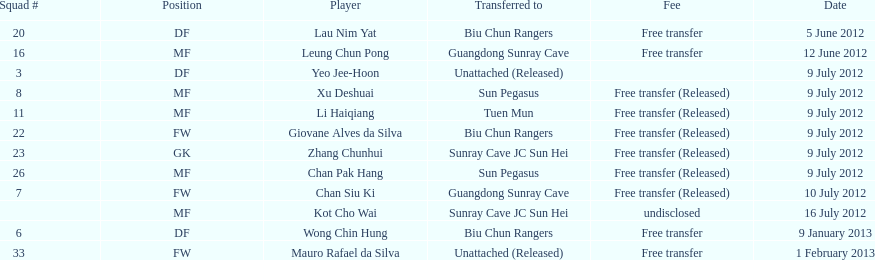What was the number of successive players released on july 9? 6. 